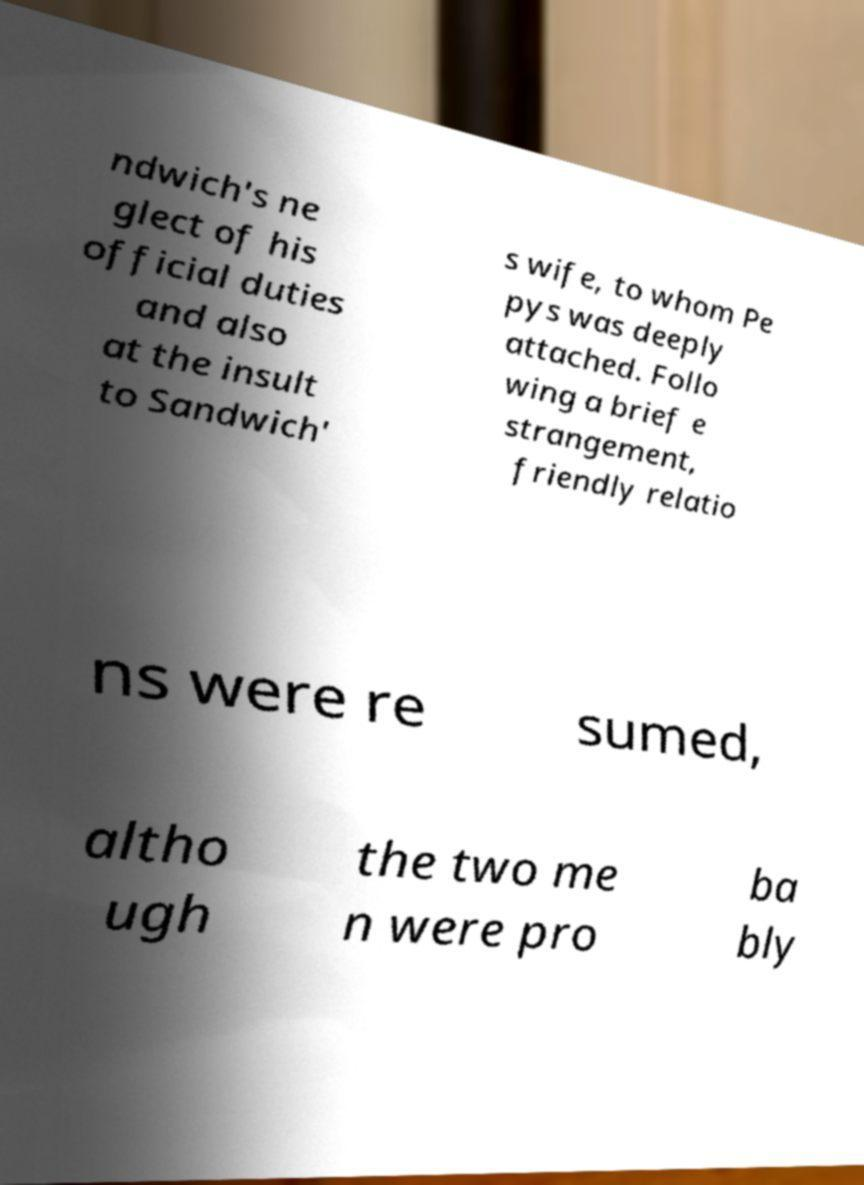Please identify and transcribe the text found in this image. ndwich's ne glect of his official duties and also at the insult to Sandwich' s wife, to whom Pe pys was deeply attached. Follo wing a brief e strangement, friendly relatio ns were re sumed, altho ugh the two me n were pro ba bly 